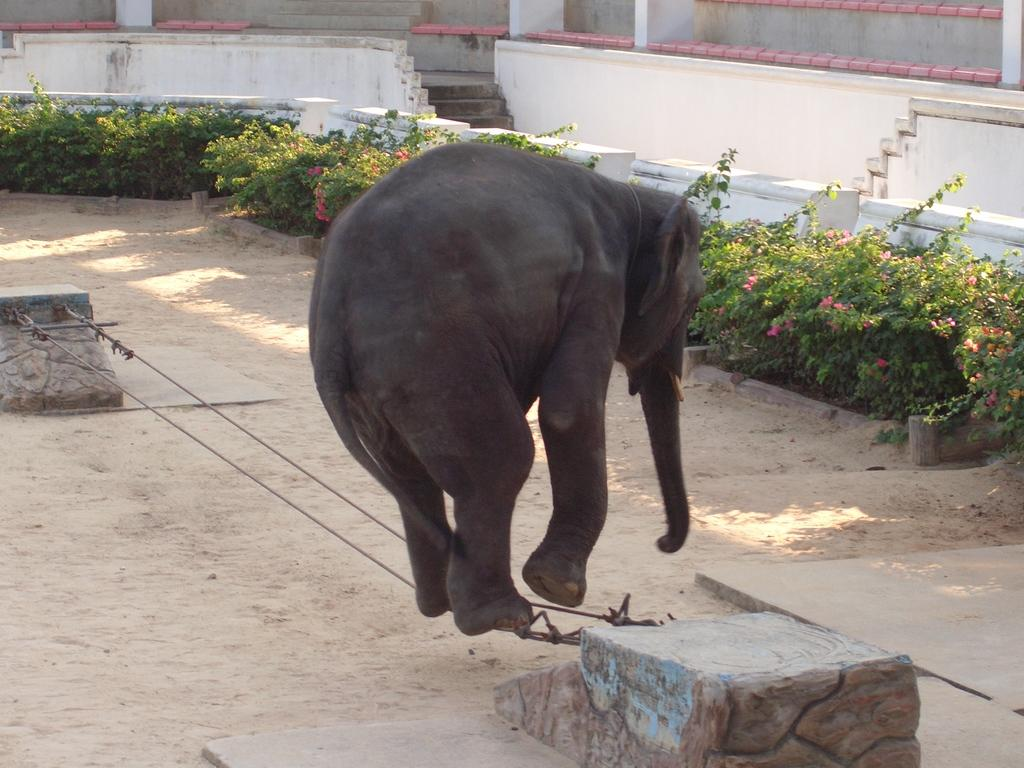What animal is the main subject of the image? There is an elephant in the image. How is the elephant being restrained or controlled? The elephant is on a rope. What structures can be seen in the background of the image? There is a wall, a staircase, and a fence in the background of the image. What type of terrain is visible in the background of the image? There is sand in the background of the image. What type of vegetation is present in the background of the image? There are plants and flowers in the background of the image. What type of music can be heard coming from the lift in the image? There is no lift present in the image, so it is not possible to determine what type of music might be heard. 